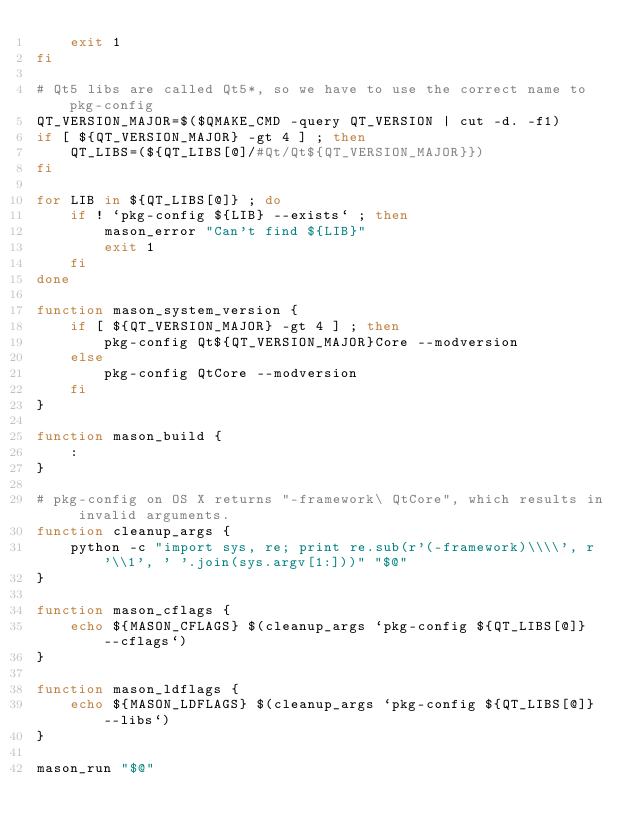Convert code to text. <code><loc_0><loc_0><loc_500><loc_500><_Bash_>    exit 1
fi

# Qt5 libs are called Qt5*, so we have to use the correct name to pkg-config
QT_VERSION_MAJOR=$($QMAKE_CMD -query QT_VERSION | cut -d. -f1)
if [ ${QT_VERSION_MAJOR} -gt 4 ] ; then
    QT_LIBS=(${QT_LIBS[@]/#Qt/Qt${QT_VERSION_MAJOR}})
fi

for LIB in ${QT_LIBS[@]} ; do
    if ! `pkg-config ${LIB} --exists` ; then
        mason_error "Can't find ${LIB}"
        exit 1
    fi
done

function mason_system_version {
    if [ ${QT_VERSION_MAJOR} -gt 4 ] ; then
        pkg-config Qt${QT_VERSION_MAJOR}Core --modversion
    else
        pkg-config QtCore --modversion
    fi
}

function mason_build {
    :
}

# pkg-config on OS X returns "-framework\ QtCore", which results in invalid arguments.
function cleanup_args {
    python -c "import sys, re; print re.sub(r'(-framework)\\\\', r'\\1', ' '.join(sys.argv[1:]))" "$@"
}

function mason_cflags {
    echo ${MASON_CFLAGS} $(cleanup_args `pkg-config ${QT_LIBS[@]} --cflags`)
}

function mason_ldflags {
    echo ${MASON_LDFLAGS} $(cleanup_args `pkg-config ${QT_LIBS[@]} --libs`)
}

mason_run "$@"
</code> 